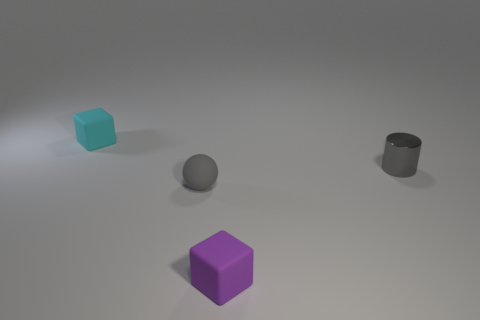What size is the gray metal cylinder?
Ensure brevity in your answer.  Small. What is the material of the small ball that is the same color as the small cylinder?
Your response must be concise. Rubber. How many small shiny objects have the same color as the rubber ball?
Offer a terse response. 1. Does the cyan rubber block have the same size as the purple object?
Make the answer very short. Yes. There is a matte block that is in front of the tiny cube on the left side of the purple matte cube; what size is it?
Provide a short and direct response. Small. Does the ball have the same color as the small rubber thing that is behind the small gray metal cylinder?
Provide a short and direct response. No. Is there a purple matte block of the same size as the cylinder?
Your answer should be compact. Yes. How big is the matte cube in front of the cyan rubber thing?
Keep it short and to the point. Small. Are there any metal things that are to the left of the small block to the right of the tiny cyan block?
Ensure brevity in your answer.  No. How many other objects are there of the same shape as the small metallic object?
Your response must be concise. 0. 